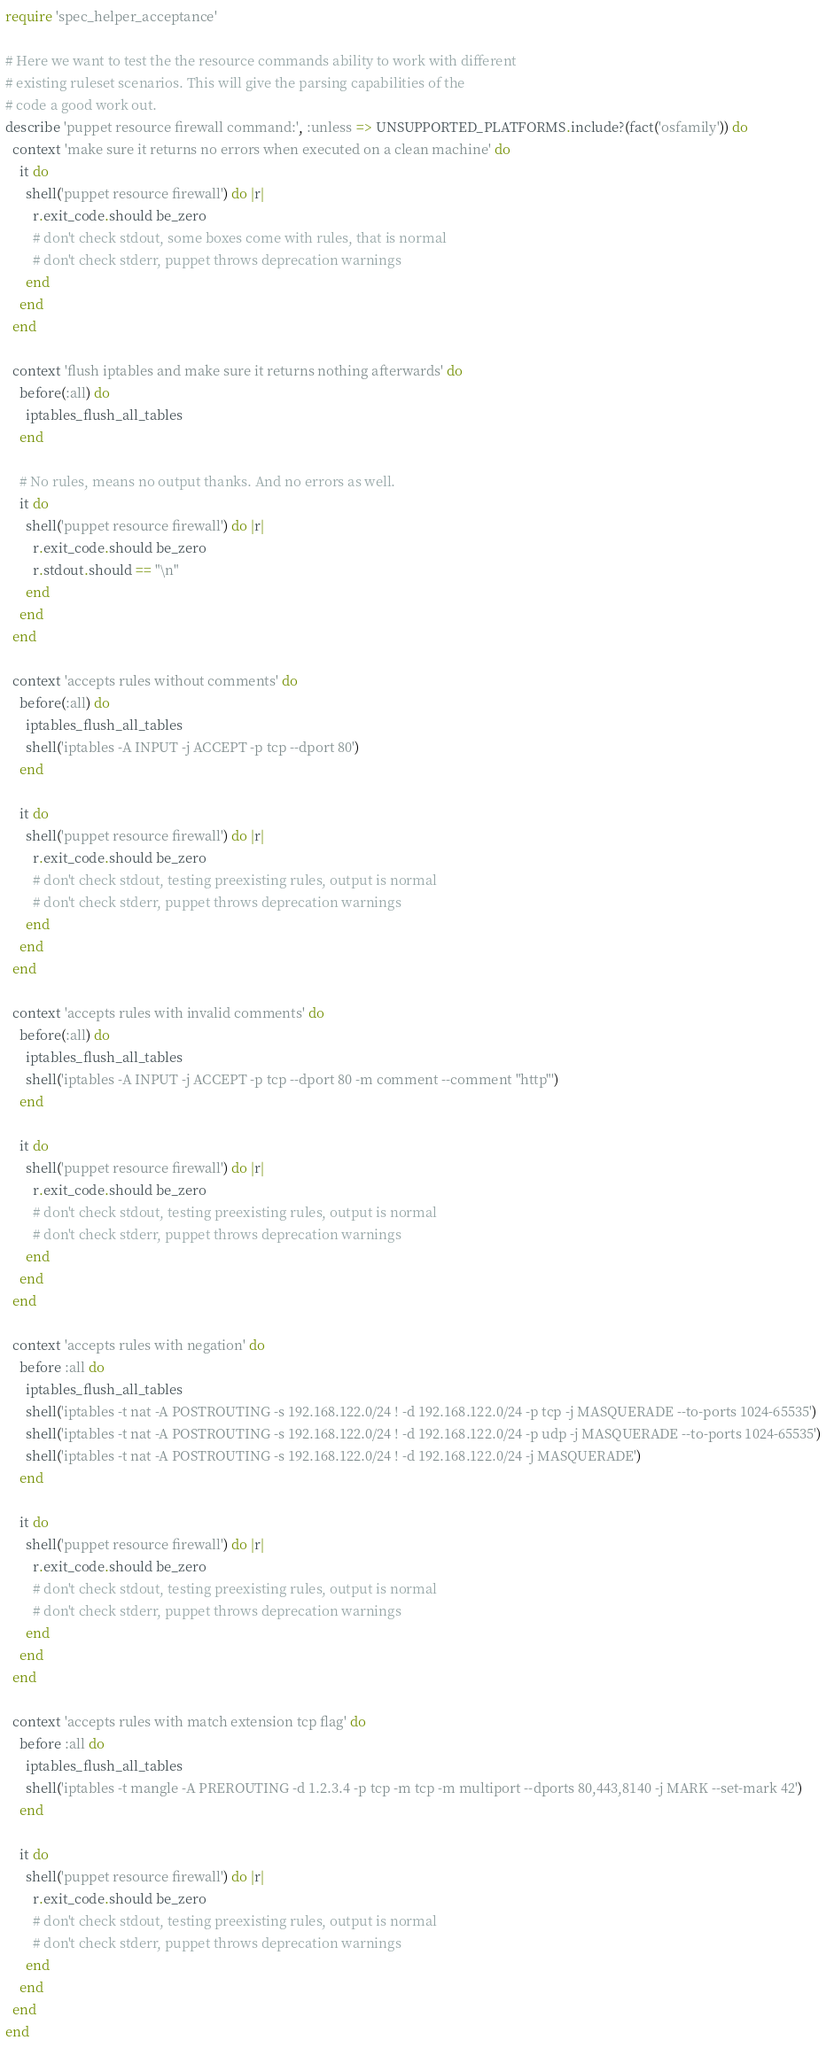<code> <loc_0><loc_0><loc_500><loc_500><_Ruby_>require 'spec_helper_acceptance'

# Here we want to test the the resource commands ability to work with different
# existing ruleset scenarios. This will give the parsing capabilities of the
# code a good work out.
describe 'puppet resource firewall command:', :unless => UNSUPPORTED_PLATFORMS.include?(fact('osfamily')) do
  context 'make sure it returns no errors when executed on a clean machine' do
    it do
      shell('puppet resource firewall') do |r|
        r.exit_code.should be_zero
        # don't check stdout, some boxes come with rules, that is normal
        # don't check stderr, puppet throws deprecation warnings
      end
    end
  end

  context 'flush iptables and make sure it returns nothing afterwards' do
    before(:all) do
      iptables_flush_all_tables
    end

    # No rules, means no output thanks. And no errors as well.
    it do
      shell('puppet resource firewall') do |r|
        r.exit_code.should be_zero
        r.stdout.should == "\n"
      end
    end
  end

  context 'accepts rules without comments' do
    before(:all) do
      iptables_flush_all_tables
      shell('iptables -A INPUT -j ACCEPT -p tcp --dport 80')
    end

    it do
      shell('puppet resource firewall') do |r|
        r.exit_code.should be_zero
        # don't check stdout, testing preexisting rules, output is normal
        # don't check stderr, puppet throws deprecation warnings
      end
    end
  end

  context 'accepts rules with invalid comments' do
    before(:all) do
      iptables_flush_all_tables
      shell('iptables -A INPUT -j ACCEPT -p tcp --dport 80 -m comment --comment "http"')
    end

    it do
      shell('puppet resource firewall') do |r|
        r.exit_code.should be_zero
        # don't check stdout, testing preexisting rules, output is normal
        # don't check stderr, puppet throws deprecation warnings
      end
    end
  end

  context 'accepts rules with negation' do
    before :all do
      iptables_flush_all_tables
      shell('iptables -t nat -A POSTROUTING -s 192.168.122.0/24 ! -d 192.168.122.0/24 -p tcp -j MASQUERADE --to-ports 1024-65535')
      shell('iptables -t nat -A POSTROUTING -s 192.168.122.0/24 ! -d 192.168.122.0/24 -p udp -j MASQUERADE --to-ports 1024-65535')
      shell('iptables -t nat -A POSTROUTING -s 192.168.122.0/24 ! -d 192.168.122.0/24 -j MASQUERADE')
    end

    it do
      shell('puppet resource firewall') do |r|
        r.exit_code.should be_zero
        # don't check stdout, testing preexisting rules, output is normal
        # don't check stderr, puppet throws deprecation warnings
      end
    end
  end

  context 'accepts rules with match extension tcp flag' do
    before :all do
      iptables_flush_all_tables
      shell('iptables -t mangle -A PREROUTING -d 1.2.3.4 -p tcp -m tcp -m multiport --dports 80,443,8140 -j MARK --set-mark 42')
    end

    it do
      shell('puppet resource firewall') do |r|
        r.exit_code.should be_zero
        # don't check stdout, testing preexisting rules, output is normal
        # don't check stderr, puppet throws deprecation warnings
      end
    end
  end
end
</code> 